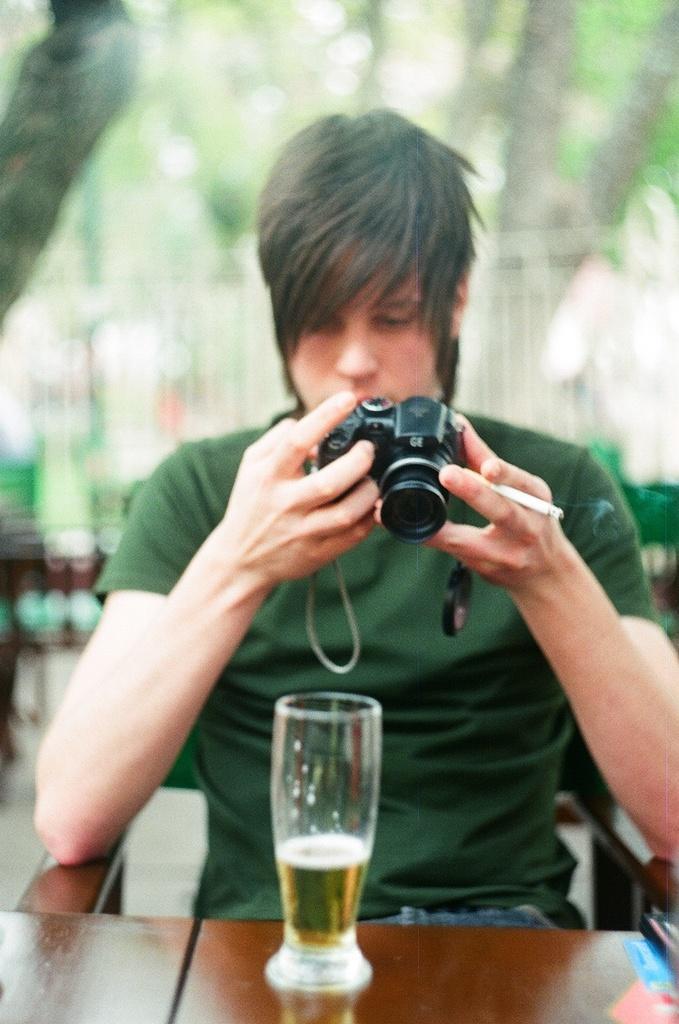In one or two sentences, can you explain what this image depicts? In this image we can see a man holding a camera and a cigarette. In front of him there is a table. On the table there is a glass with a drink. And he is sitting on a chair. In the background it is blur. 